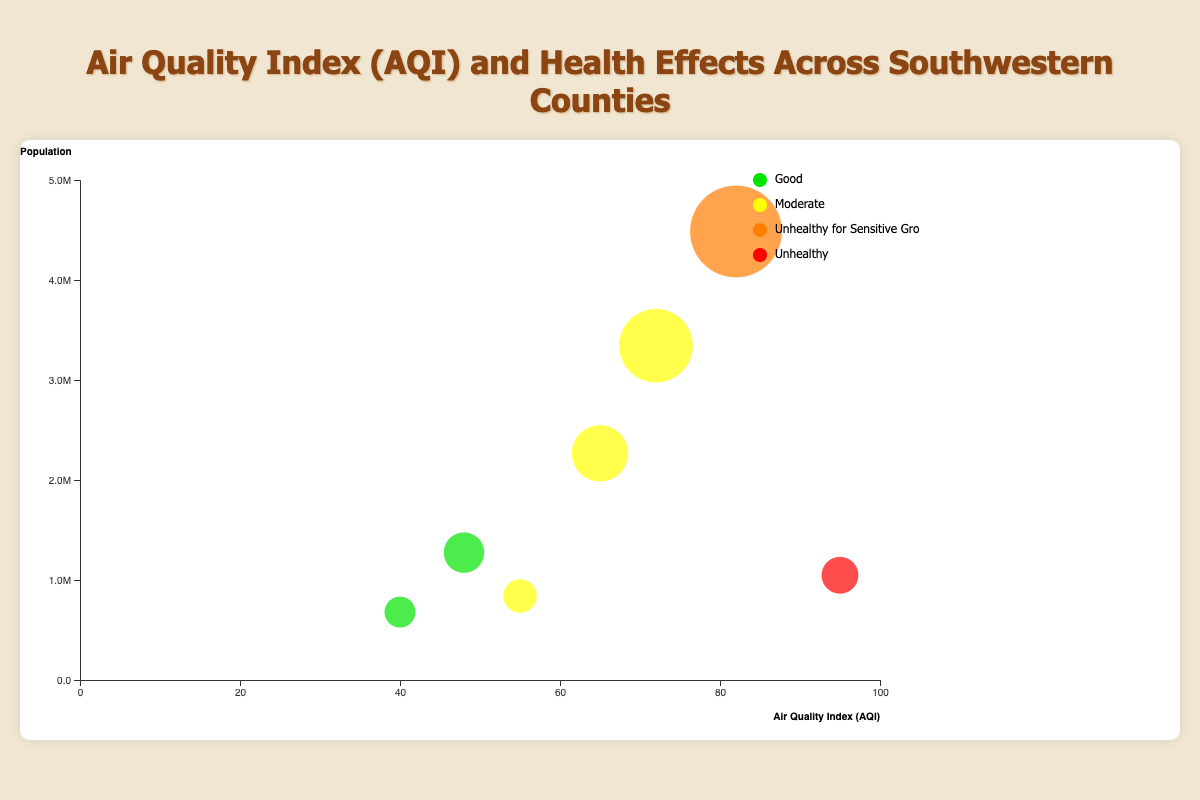What's the title of the figure? The title of the figure is placed at the top and summarizes the content of the chart. It helps in understanding what the chart represents.
Answer: Air Quality Index (AQI) and Health Effects Across Southwestern Counties How many counties are represented in the chart? By counting the number of distinct bubbles on the chart, we can determine the number of counties represented.
Answer: 7 Which county has the highest AQI? Locate the bubble furthest to the right on the AQI axis to identify the county with the highest AQI.
Answer: Pima County Which county has the largest population? Identify the bubble with the largest size since the size is proportional to the population.
Answer: Maricopa County What is the health effect for a county with an AQI of 40? Find the bubble that is located at the AQI value of 40 on the x-axis and look at its color or tooltip for health effects.
Answer: Good What is the average AQI of counties in Texas? Identify the Texas counties (El Paso and Travis), sum their AQIs (55 + 48 = 103), and divide by the number of counties (2).
Answer: 51.5 Which has a better air quality, Clark County or San Diego County? Compare the AQI values of Clark County (65) and San Diego County (72); a lower AQI indicates better air quality.
Answer: Clark County How many counties have an AQI categorized as "Moderate"? Count the bubbles that are colored to represent "Moderate" in the chart legend.
Answer: 3 If you combine the populations of counties with "Good" air quality, what is the total population? Identify the bubbles with "Good" air quality (Bernalillo and Travis), sum their populations (679121 + 1273954).
Answer: 1953075 Which health effect category has the most counties? Count the number of bubbles for each health effect category and find the one with the highest count.
Answer: Moderate 